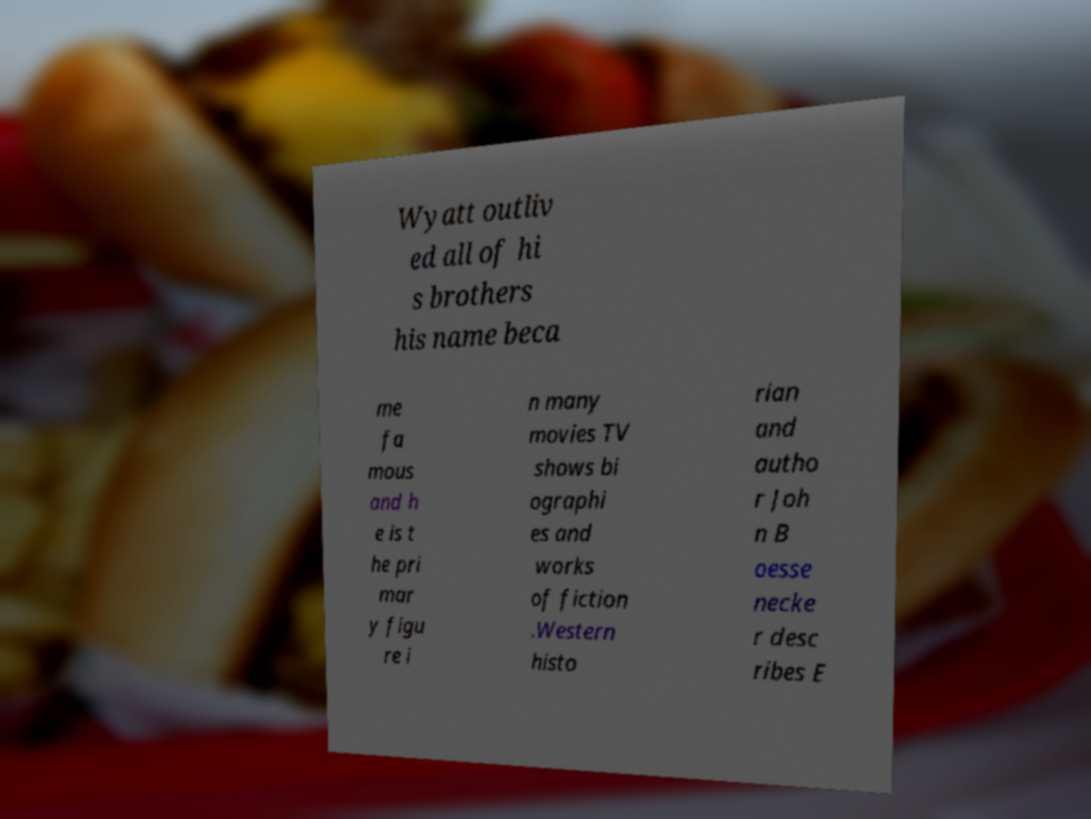There's text embedded in this image that I need extracted. Can you transcribe it verbatim? Wyatt outliv ed all of hi s brothers his name beca me fa mous and h e is t he pri mar y figu re i n many movies TV shows bi ographi es and works of fiction .Western histo rian and autho r Joh n B oesse necke r desc ribes E 